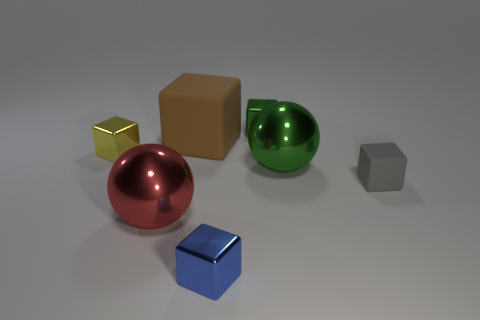There is a red thing; is its shape the same as the large metal object that is right of the red metal object? Yes, the red object, which is a sphere, shares the same geometric shape as the large green spherical object located to its right. 